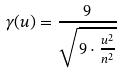<formula> <loc_0><loc_0><loc_500><loc_500>\gamma ( u ) = \frac { 9 } { \sqrt { 9 \cdot \frac { u ^ { 2 } } { n ^ { 2 } } } }</formula> 